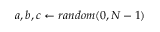<formula> <loc_0><loc_0><loc_500><loc_500>a , b , c \gets r a n d o m ( 0 , N - 1 )</formula> 